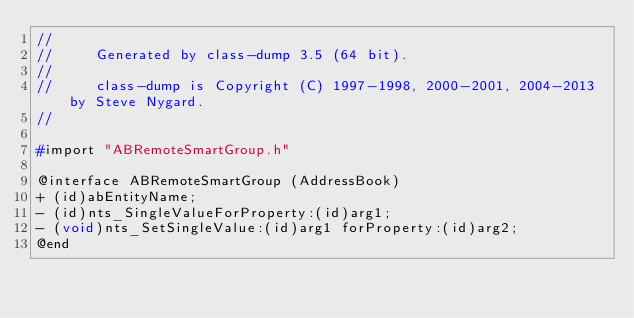<code> <loc_0><loc_0><loc_500><loc_500><_C_>//
//     Generated by class-dump 3.5 (64 bit).
//
//     class-dump is Copyright (C) 1997-1998, 2000-2001, 2004-2013 by Steve Nygard.
//

#import "ABRemoteSmartGroup.h"

@interface ABRemoteSmartGroup (AddressBook)
+ (id)abEntityName;
- (id)nts_SingleValueForProperty:(id)arg1;
- (void)nts_SetSingleValue:(id)arg1 forProperty:(id)arg2;
@end

</code> 